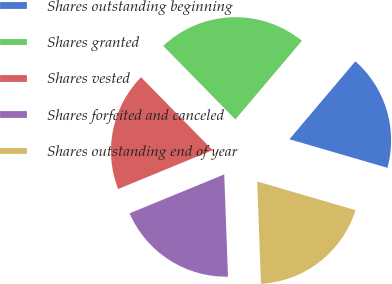Convert chart. <chart><loc_0><loc_0><loc_500><loc_500><pie_chart><fcel>Shares outstanding beginning<fcel>Shares granted<fcel>Shares vested<fcel>Shares forfeited and canceled<fcel>Shares outstanding end of year<nl><fcel>18.34%<fcel>23.52%<fcel>18.86%<fcel>19.38%<fcel>19.9%<nl></chart> 